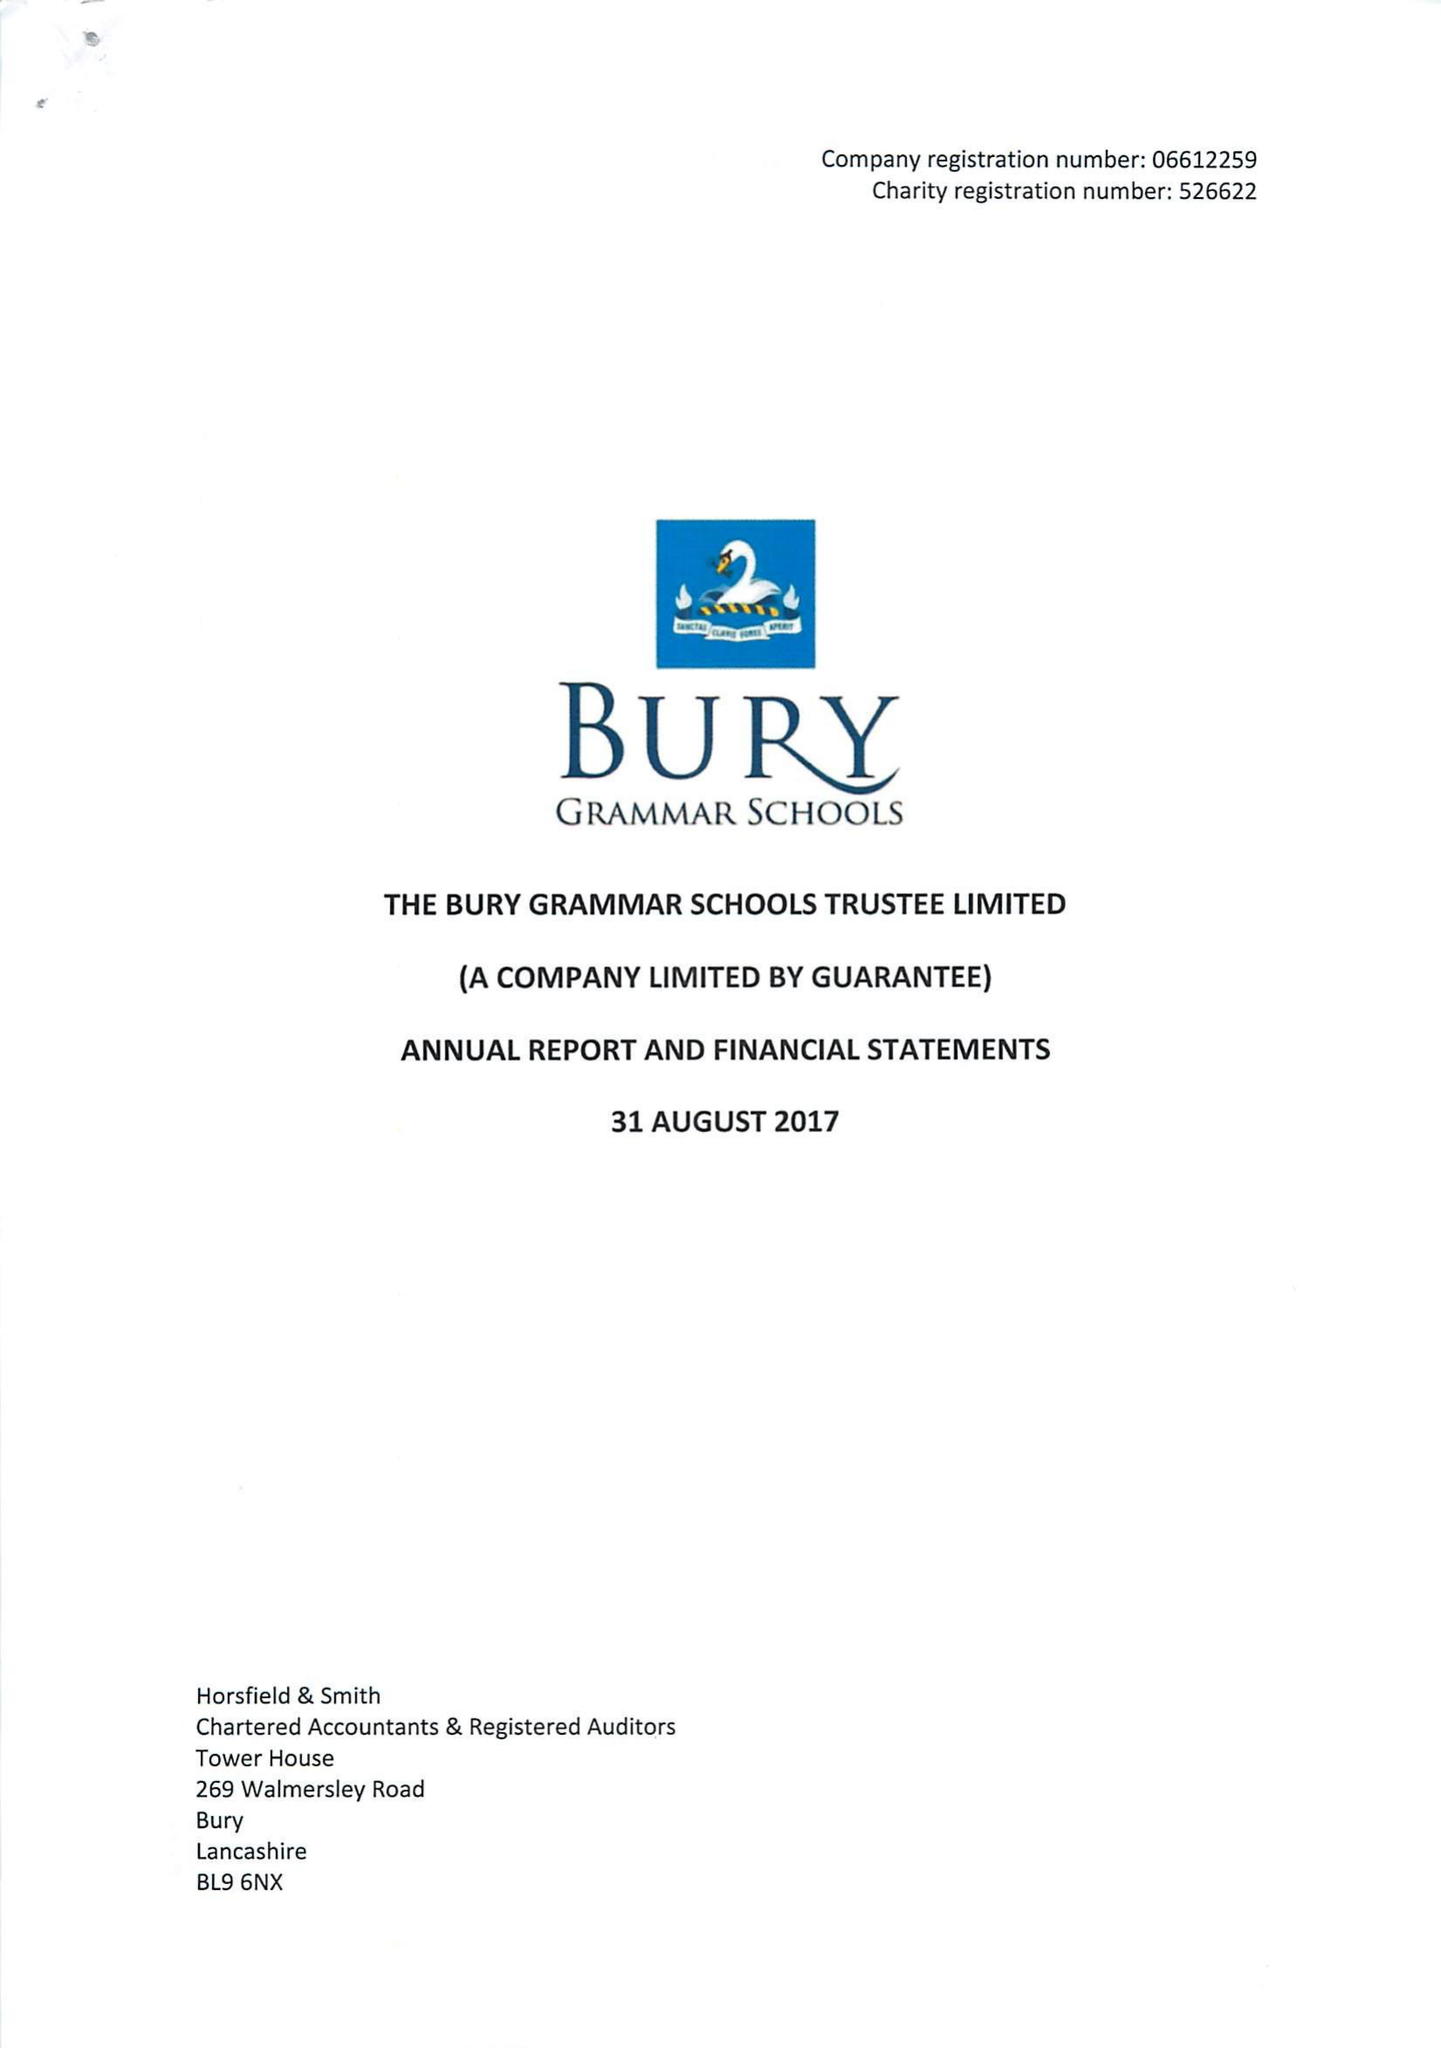What is the value for the address__post_town?
Answer the question using a single word or phrase. BURY 